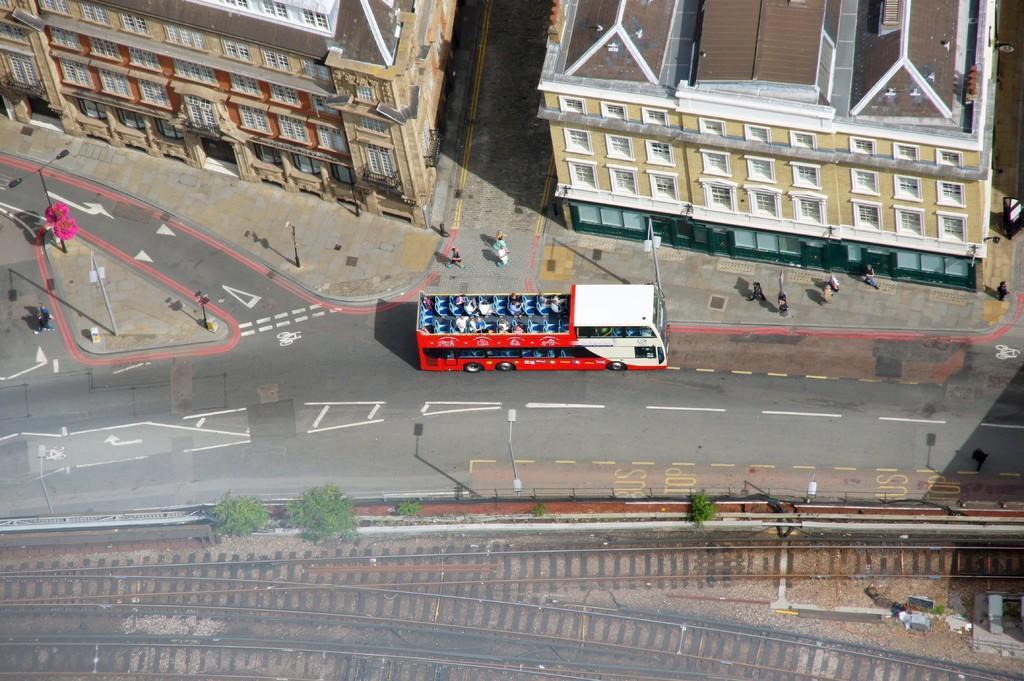In one or two sentences, can you explain what this image depicts? This image is clicked from the top view. In the center there there is a road. There is a bus moving the road. Beside the road there is a walkway. There are street light poles and people walking on the walkway. At the top there are buildings. At the bottom there are railway tracks. Beside the tracks there plants on the ground. 